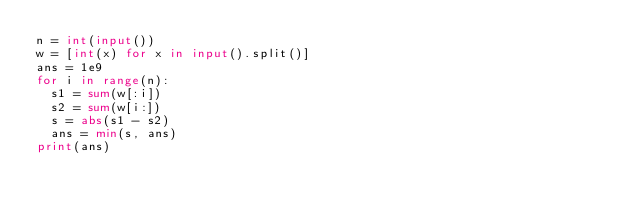<code> <loc_0><loc_0><loc_500><loc_500><_Python_>n = int(input())
w = [int(x) for x in input().split()]
ans = 1e9
for i in range(n):
  s1 = sum(w[:i])
  s2 = sum(w[i:])
  s = abs(s1 - s2)
  ans = min(s, ans)
print(ans)</code> 